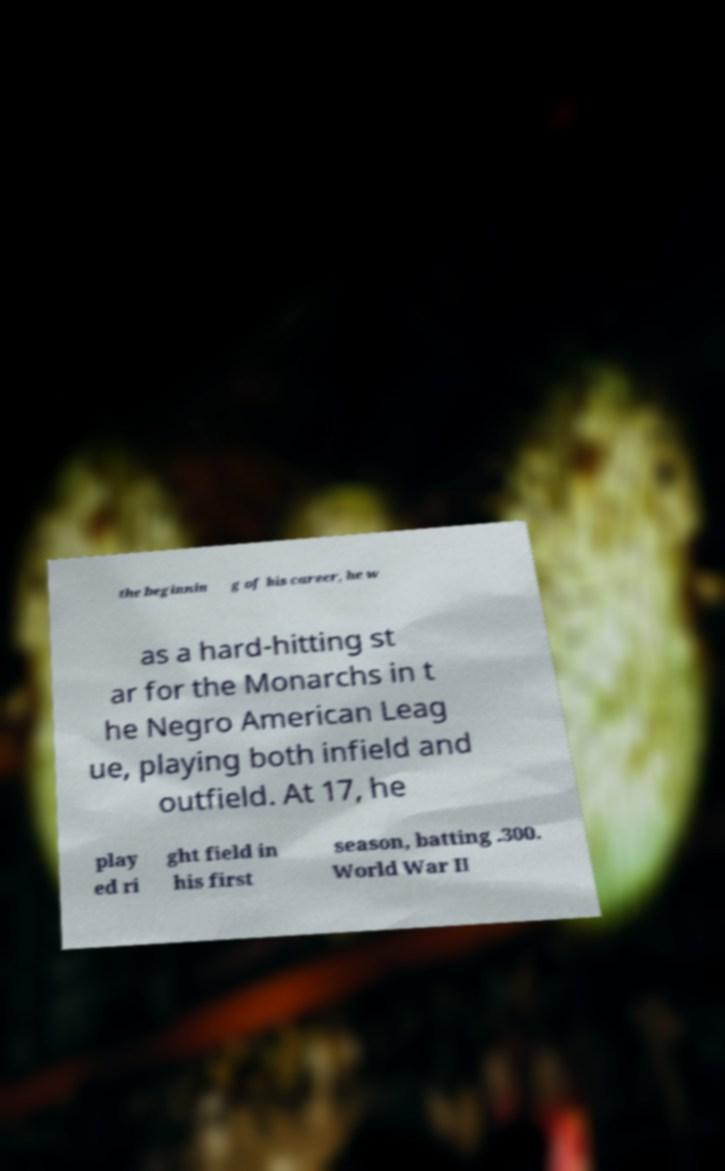I need the written content from this picture converted into text. Can you do that? the beginnin g of his career, he w as a hard-hitting st ar for the Monarchs in t he Negro American Leag ue, playing both infield and outfield. At 17, he play ed ri ght field in his first season, batting .300. World War II 